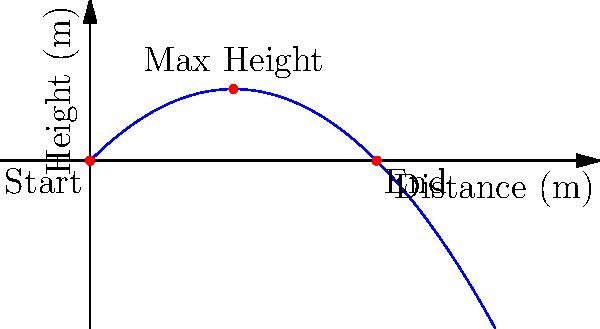As a former NFL quarterback, you're demonstrating a perfect 45-degree angle throw to some young players. If you launch the football with an initial velocity of 25 m/s, what is the maximum height the football will reach, and how far will it travel horizontally before hitting the ground? (Assume no air resistance and use g = 9.8 m/s^2 for acceleration due to gravity.) Let's break this down step-by-step:

1) For a projectile launched at an angle θ with initial velocity v0, we can use these equations:
   
   Maximum height: $h_{max} = \frac{(v_0 \sin \theta)^2}{2g}$
   
   Range: $R = \frac{v_0^2 \sin 2\theta}{g}$

2) We're given:
   $v_0 = 25$ m/s
   $\theta = 45°$
   $g = 9.8$ m/s^2

3) To find the maximum height:
   $h_{max} = \frac{(25 \sin 45°)^2}{2(9.8)}$
   
   $\sin 45° = \frac{1}{\sqrt{2}} \approx 0.707$
   
   $h_{max} = \frac{(25 * 0.707)^2}{2(9.8)} \approx 15.92$ m

4) To find the range:
   $R = \frac{25^2 \sin (2*45°)}{9.8}$
   
   $\sin 90° = 1$
   
   $R = \frac{25^2 * 1}{9.8} \approx 63.78$ m

Therefore, the football will reach a maximum height of about 15.92 meters and travel horizontally about 63.78 meters before hitting the ground.
Answer: Maximum height: 15.92 m, Horizontal distance: 63.78 m 